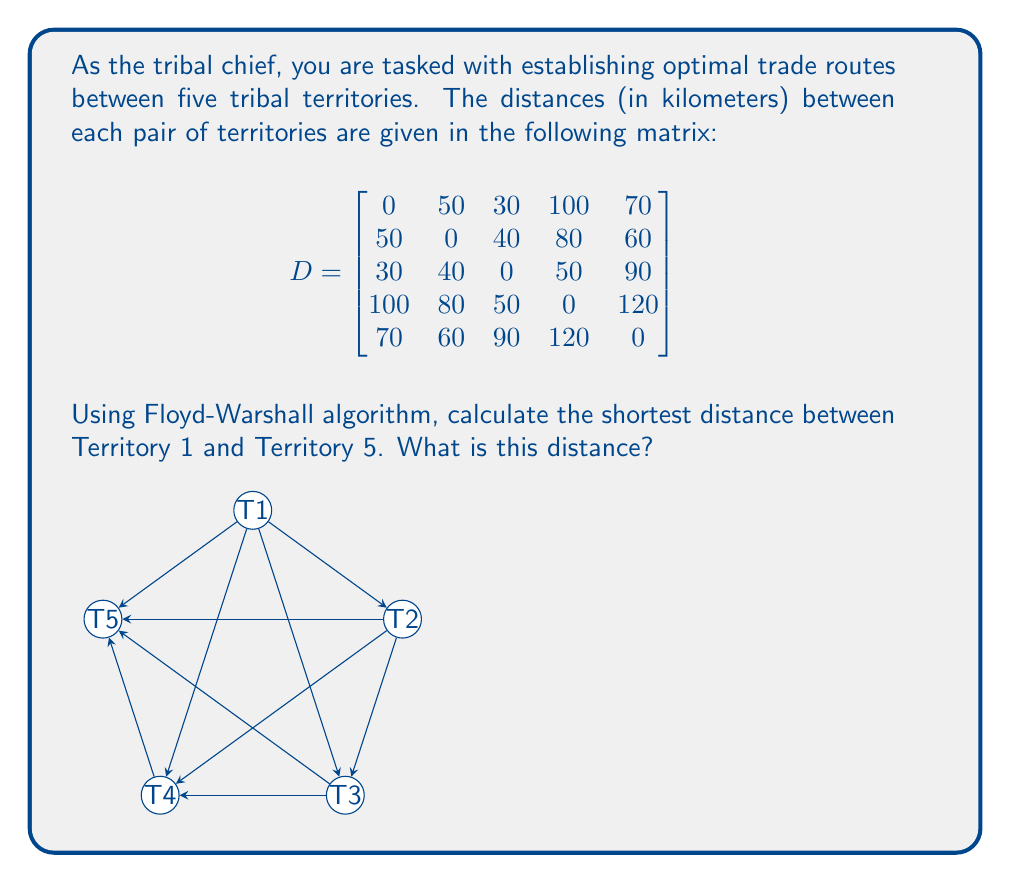Can you solve this math problem? To solve this problem, we'll use the Floyd-Warshall algorithm to find the shortest paths between all pairs of territories. The algorithm works by iteratively considering each vertex as an intermediate point and updating the distances if a shorter path is found.

Let's denote $d_{ij}^{(k)}$ as the shortest distance from territory $i$ to territory $j$ using territories $1$ through $k$ as intermediate points.

The recurrence relation for the Floyd-Warshall algorithm is:

$$d_{ij}^{(k)} = \min(d_{ij}^{(k-1)}, d_{ik}^{(k-1)} + d_{kj}^{(k-1)})$$

We'll update the matrix $D$ in place. Here's the step-by-step process:

1) Initially, $D^{(0)} = D$ (the given matrix)

2) For $k = 1$ to $5$, we update $D^{(k)}$ using the recurrence relation.

3) After the final iteration, $D^{(5)}$ will contain the shortest distances between all pairs of territories.

Let's focus on the entry $d_{15}$ (distance from Territory 1 to Territory 5) in each iteration:

- Initially: $d_{15}^{(0)} = 70$
- After $k=1$: $d_{15}^{(1)} = \min(70, 50 + 70) = 70$
- After $k=2$: $d_{15}^{(2)} = \min(70, 50 + 60) = 70$
- After $k=3$: $d_{15}^{(3)} = \min(70, 30 + 90) = 70$
- After $k=4$: $d_{15}^{(4)} = \min(70, 100 + 120) = 70$
- After $k=5$: $d_{15}^{(5)} = 70$ (no change)

Therefore, the shortest distance from Territory 1 to Territory 5 is 70 km.
Answer: The shortest distance between Territory 1 and Territory 5 is 70 km. 